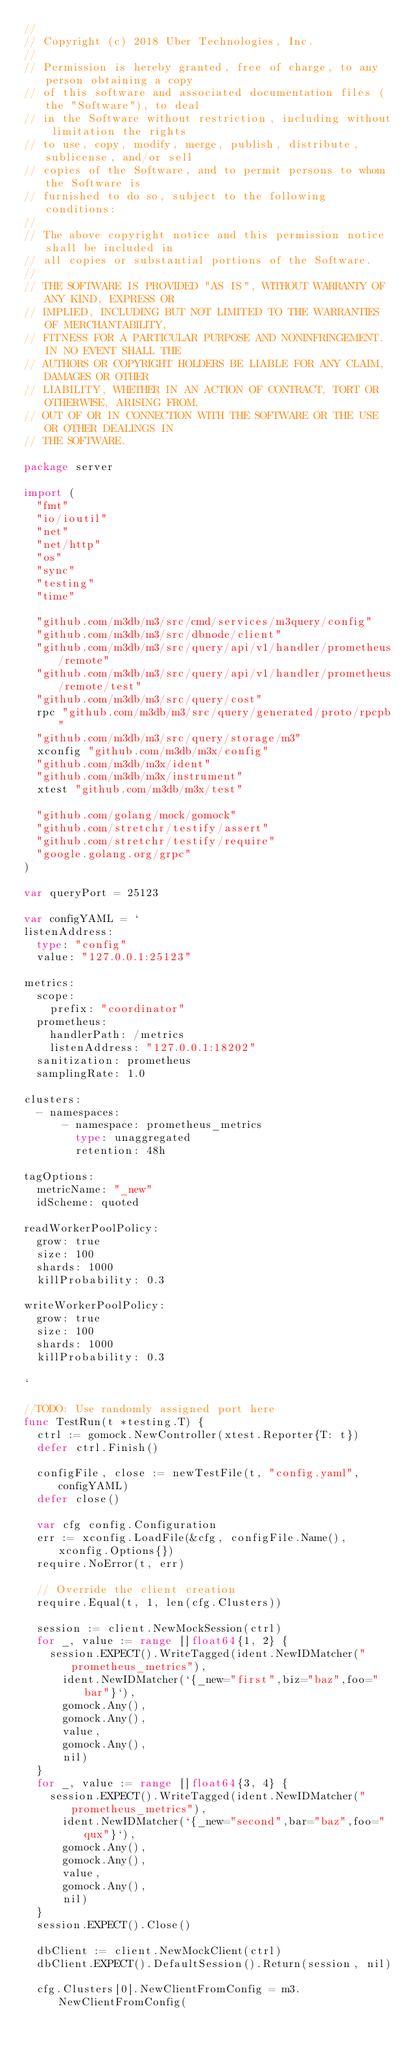Convert code to text. <code><loc_0><loc_0><loc_500><loc_500><_Go_>//
// Copyright (c) 2018 Uber Technologies, Inc.
//
// Permission is hereby granted, free of charge, to any person obtaining a copy
// of this software and associated documentation files (the "Software"), to deal
// in the Software without restriction, including without limitation the rights
// to use, copy, modify, merge, publish, distribute, sublicense, and/or sell
// copies of the Software, and to permit persons to whom the Software is
// furnished to do so, subject to the following conditions:
//
// The above copyright notice and this permission notice shall be included in
// all copies or substantial portions of the Software.
//
// THE SOFTWARE IS PROVIDED "AS IS", WITHOUT WARRANTY OF ANY KIND, EXPRESS OR
// IMPLIED, INCLUDING BUT NOT LIMITED TO THE WARRANTIES OF MERCHANTABILITY,
// FITNESS FOR A PARTICULAR PURPOSE AND NONINFRINGEMENT. IN NO EVENT SHALL THE
// AUTHORS OR COPYRIGHT HOLDERS BE LIABLE FOR ANY CLAIM, DAMAGES OR OTHER
// LIABILITY, WHETHER IN AN ACTION OF CONTRACT, TORT OR OTHERWISE, ARISING FROM,
// OUT OF OR IN CONNECTION WITH THE SOFTWARE OR THE USE OR OTHER DEALINGS IN
// THE SOFTWARE.

package server

import (
	"fmt"
	"io/ioutil"
	"net"
	"net/http"
	"os"
	"sync"
	"testing"
	"time"

	"github.com/m3db/m3/src/cmd/services/m3query/config"
	"github.com/m3db/m3/src/dbnode/client"
	"github.com/m3db/m3/src/query/api/v1/handler/prometheus/remote"
	"github.com/m3db/m3/src/query/api/v1/handler/prometheus/remote/test"
	"github.com/m3db/m3/src/query/cost"
	rpc "github.com/m3db/m3/src/query/generated/proto/rpcpb"
	"github.com/m3db/m3/src/query/storage/m3"
	xconfig "github.com/m3db/m3x/config"
	"github.com/m3db/m3x/ident"
	"github.com/m3db/m3x/instrument"
	xtest "github.com/m3db/m3x/test"

	"github.com/golang/mock/gomock"
	"github.com/stretchr/testify/assert"
	"github.com/stretchr/testify/require"
	"google.golang.org/grpc"
)

var queryPort = 25123

var configYAML = `
listenAddress:
  type: "config"
  value: "127.0.0.1:25123"

metrics:
  scope:
    prefix: "coordinator"
  prometheus:
    handlerPath: /metrics
    listenAddress: "127.0.0.1:18202"
  sanitization: prometheus
  samplingRate: 1.0

clusters:
  - namespaces:
      - namespace: prometheus_metrics
        type: unaggregated
        retention: 48h

tagOptions:
  metricName: "_new"
  idScheme: quoted

readWorkerPoolPolicy:
  grow: true
  size: 100
  shards: 1000
  killProbability: 0.3

writeWorkerPoolPolicy:
  grow: true
  size: 100
  shards: 1000
  killProbability: 0.3

`

//TODO: Use randomly assigned port here
func TestRun(t *testing.T) {
	ctrl := gomock.NewController(xtest.Reporter{T: t})
	defer ctrl.Finish()

	configFile, close := newTestFile(t, "config.yaml", configYAML)
	defer close()

	var cfg config.Configuration
	err := xconfig.LoadFile(&cfg, configFile.Name(), xconfig.Options{})
	require.NoError(t, err)

	// Override the client creation
	require.Equal(t, 1, len(cfg.Clusters))

	session := client.NewMockSession(ctrl)
	for _, value := range []float64{1, 2} {
		session.EXPECT().WriteTagged(ident.NewIDMatcher("prometheus_metrics"),
			ident.NewIDMatcher(`{_new="first",biz="baz",foo="bar"}`),
			gomock.Any(),
			gomock.Any(),
			value,
			gomock.Any(),
			nil)
	}
	for _, value := range []float64{3, 4} {
		session.EXPECT().WriteTagged(ident.NewIDMatcher("prometheus_metrics"),
			ident.NewIDMatcher(`{_new="second",bar="baz",foo="qux"}`),
			gomock.Any(),
			gomock.Any(),
			value,
			gomock.Any(),
			nil)
	}
	session.EXPECT().Close()

	dbClient := client.NewMockClient(ctrl)
	dbClient.EXPECT().DefaultSession().Return(session, nil)

	cfg.Clusters[0].NewClientFromConfig = m3.NewClientFromConfig(</code> 